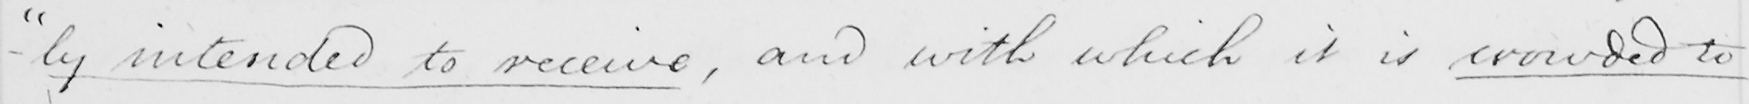Can you read and transcribe this handwriting? " intended to receive , and with which it is crowded to 